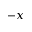<formula> <loc_0><loc_0><loc_500><loc_500>- x</formula> 